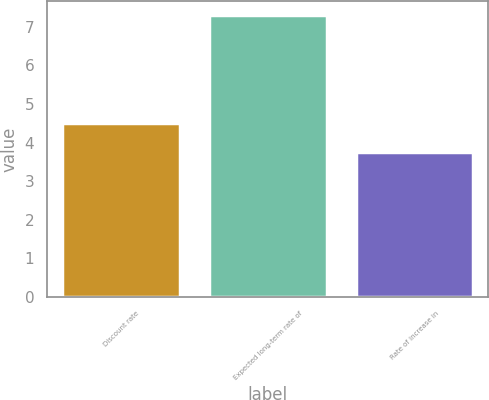Convert chart. <chart><loc_0><loc_0><loc_500><loc_500><bar_chart><fcel>Discount rate<fcel>Expected long-term rate of<fcel>Rate of increase in<nl><fcel>4.5<fcel>7.3<fcel>3.75<nl></chart> 